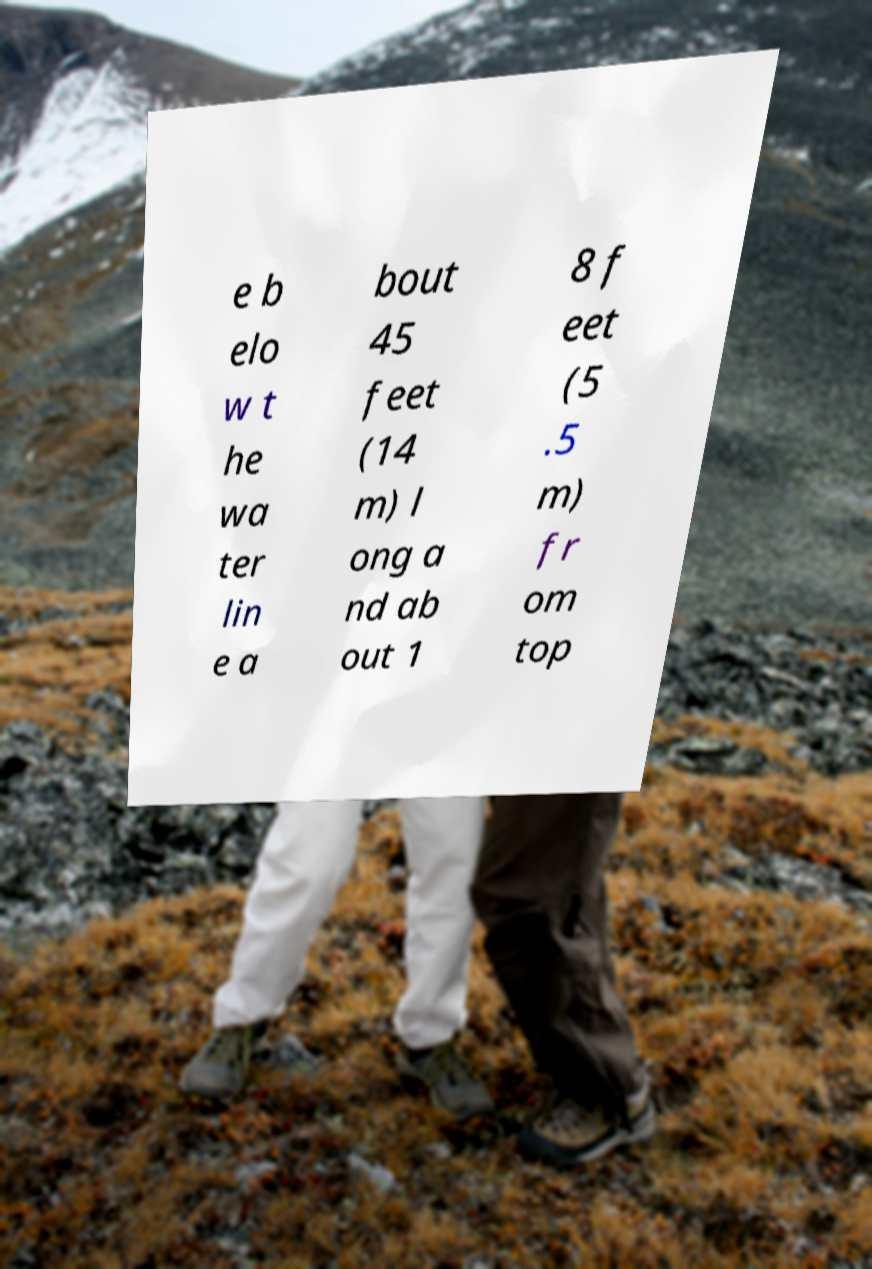There's text embedded in this image that I need extracted. Can you transcribe it verbatim? e b elo w t he wa ter lin e a bout 45 feet (14 m) l ong a nd ab out 1 8 f eet (5 .5 m) fr om top 